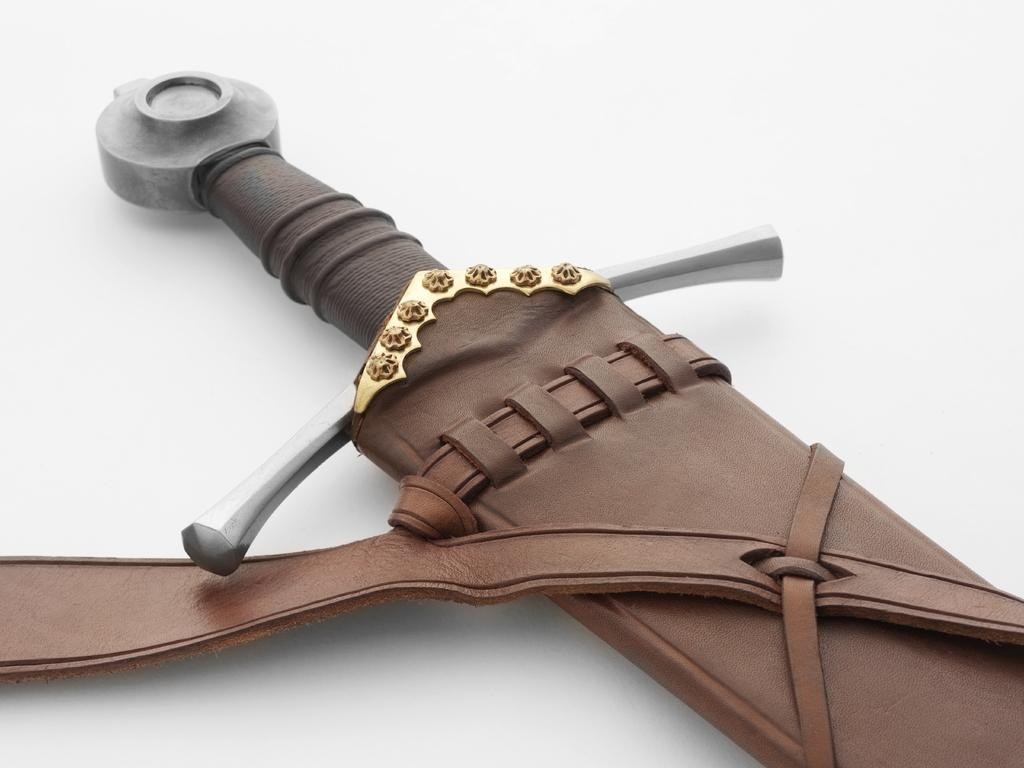What object is present in the image? There is a sword in the image. Where is the sword located? The sword is placed on a table. What type of car is parked next to the sword in the image? There is no car present in the image; it only features a sword placed on a table. 